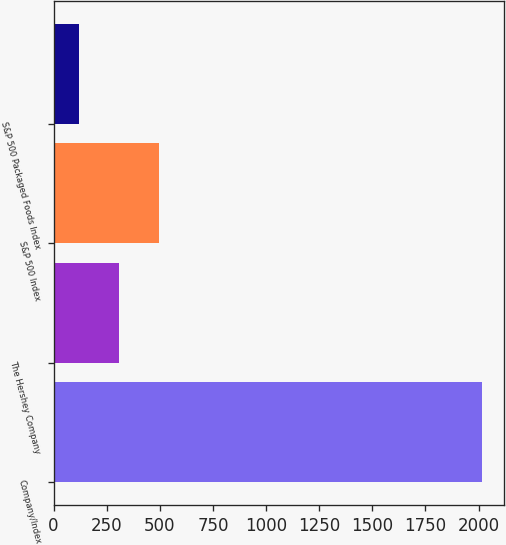<chart> <loc_0><loc_0><loc_500><loc_500><bar_chart><fcel>Company/Index<fcel>The Hershey Company<fcel>S&P 500 Index<fcel>S&P 500 Packaged Foods Index<nl><fcel>2018<fcel>308<fcel>498<fcel>118<nl></chart> 